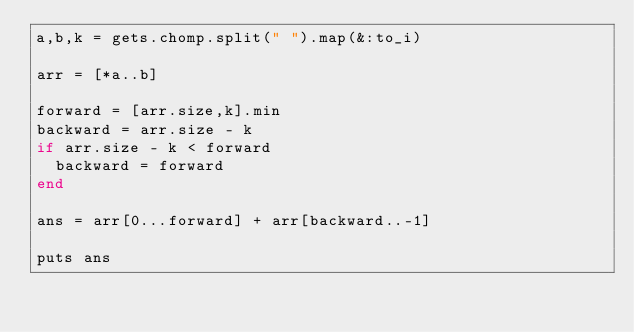<code> <loc_0><loc_0><loc_500><loc_500><_Ruby_>a,b,k = gets.chomp.split(" ").map(&:to_i)

arr = [*a..b]

forward = [arr.size,k].min
backward = arr.size - k
if arr.size - k < forward
  backward = forward
end

ans = arr[0...forward] + arr[backward..-1]

puts ans</code> 